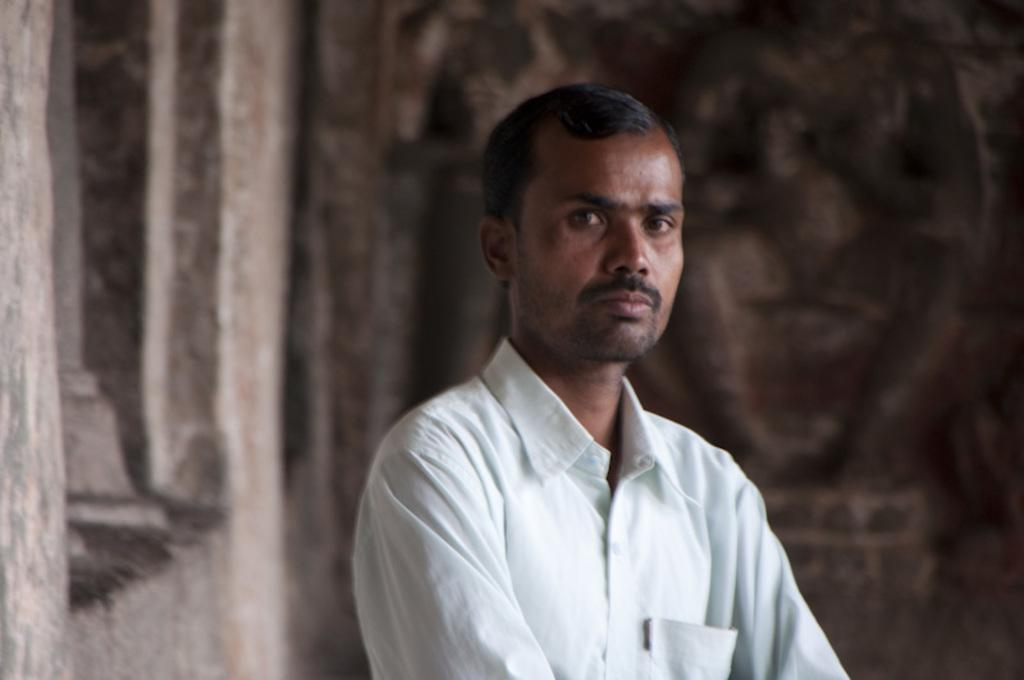Who is present in the image? There is a man in the image. What is the man wearing? The man is wearing a white shirt. What can be seen in the background of the image? There is a wall in the background of the image. What is on the wall? There are engravings on the wall. What type of map can be seen on the bed in the image? There is no bed or map present in the image. Is the man driving a vehicle in the image? There is no vehicle or driving activity depicted in the image. 